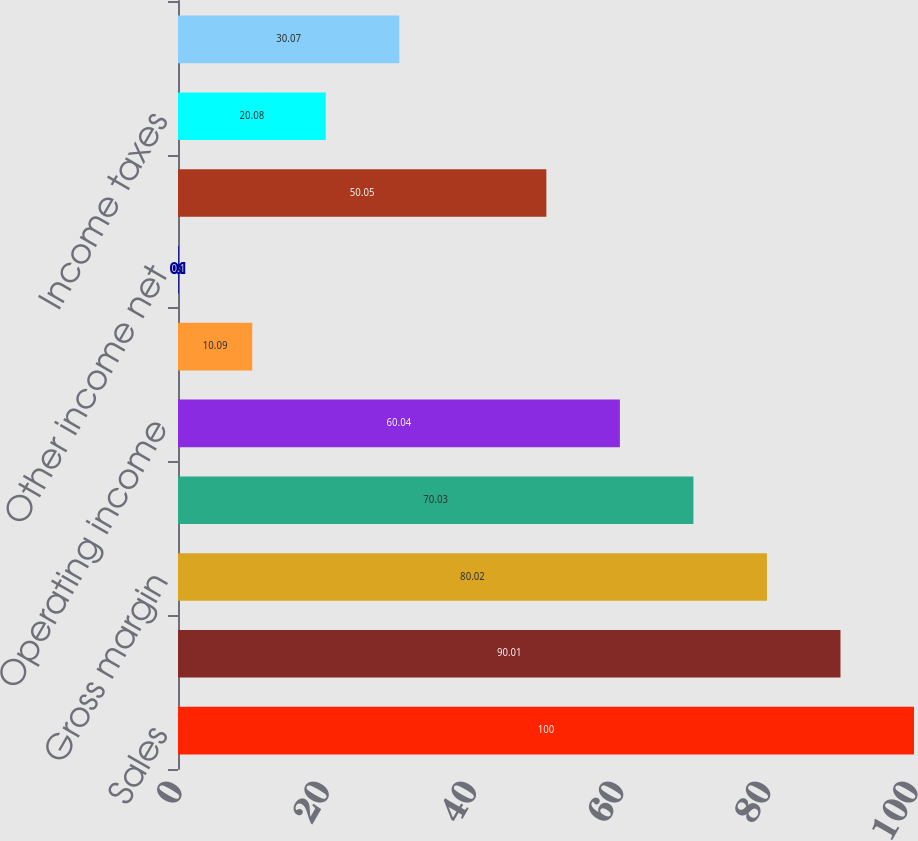Convert chart to OTSL. <chart><loc_0><loc_0><loc_500><loc_500><bar_chart><fcel>Sales<fcel>Cost of sales<fcel>Gross margin<fcel>Operating expenses<fcel>Operating income<fcel>Interest expense<fcel>Other income net<fcel>Earnings before income taxes<fcel>Income taxes<fcel>Earnings before cumulative<nl><fcel>100<fcel>90.01<fcel>80.02<fcel>70.03<fcel>60.04<fcel>10.09<fcel>0.1<fcel>50.05<fcel>20.08<fcel>30.07<nl></chart> 